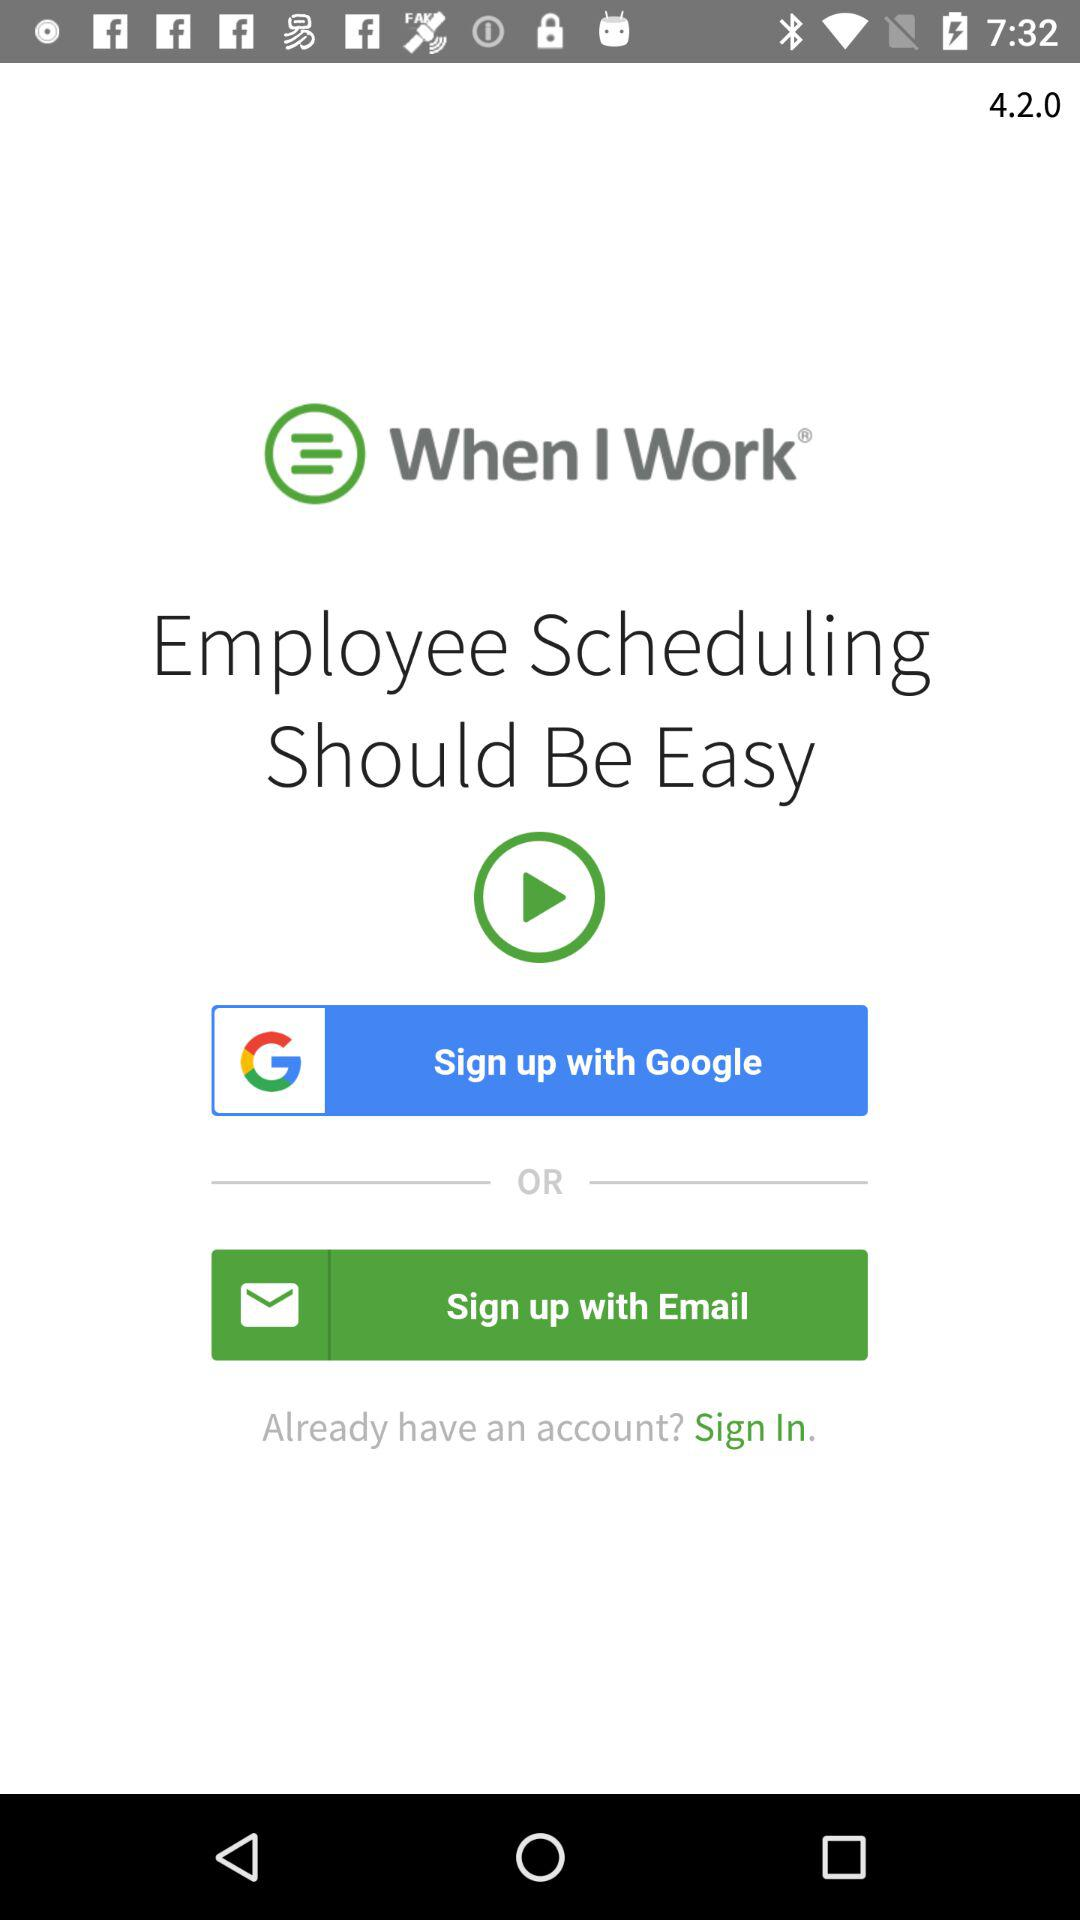Through what applications can we sign up? You can sign up through "Google". 